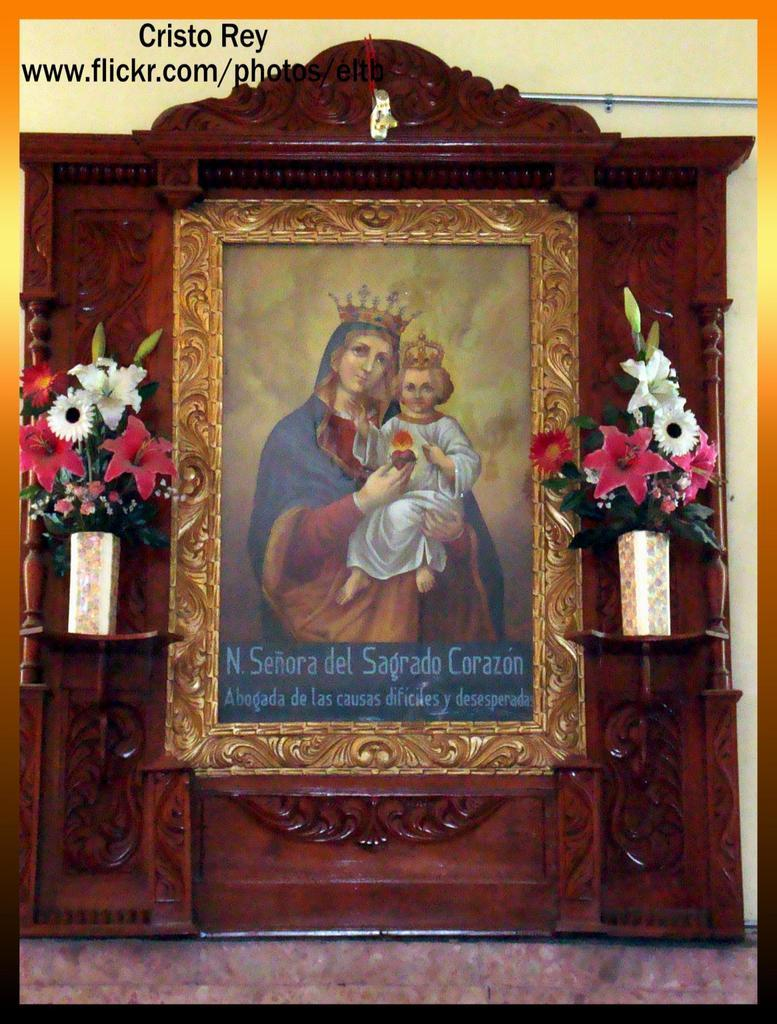<image>
Render a clear and concise summary of the photo. A picture of Mary and Christ with a flickr address above it 